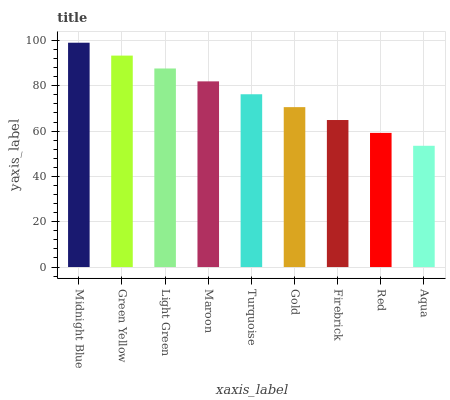Is Green Yellow the minimum?
Answer yes or no. No. Is Green Yellow the maximum?
Answer yes or no. No. Is Midnight Blue greater than Green Yellow?
Answer yes or no. Yes. Is Green Yellow less than Midnight Blue?
Answer yes or no. Yes. Is Green Yellow greater than Midnight Blue?
Answer yes or no. No. Is Midnight Blue less than Green Yellow?
Answer yes or no. No. Is Turquoise the high median?
Answer yes or no. Yes. Is Turquoise the low median?
Answer yes or no. Yes. Is Gold the high median?
Answer yes or no. No. Is Maroon the low median?
Answer yes or no. No. 